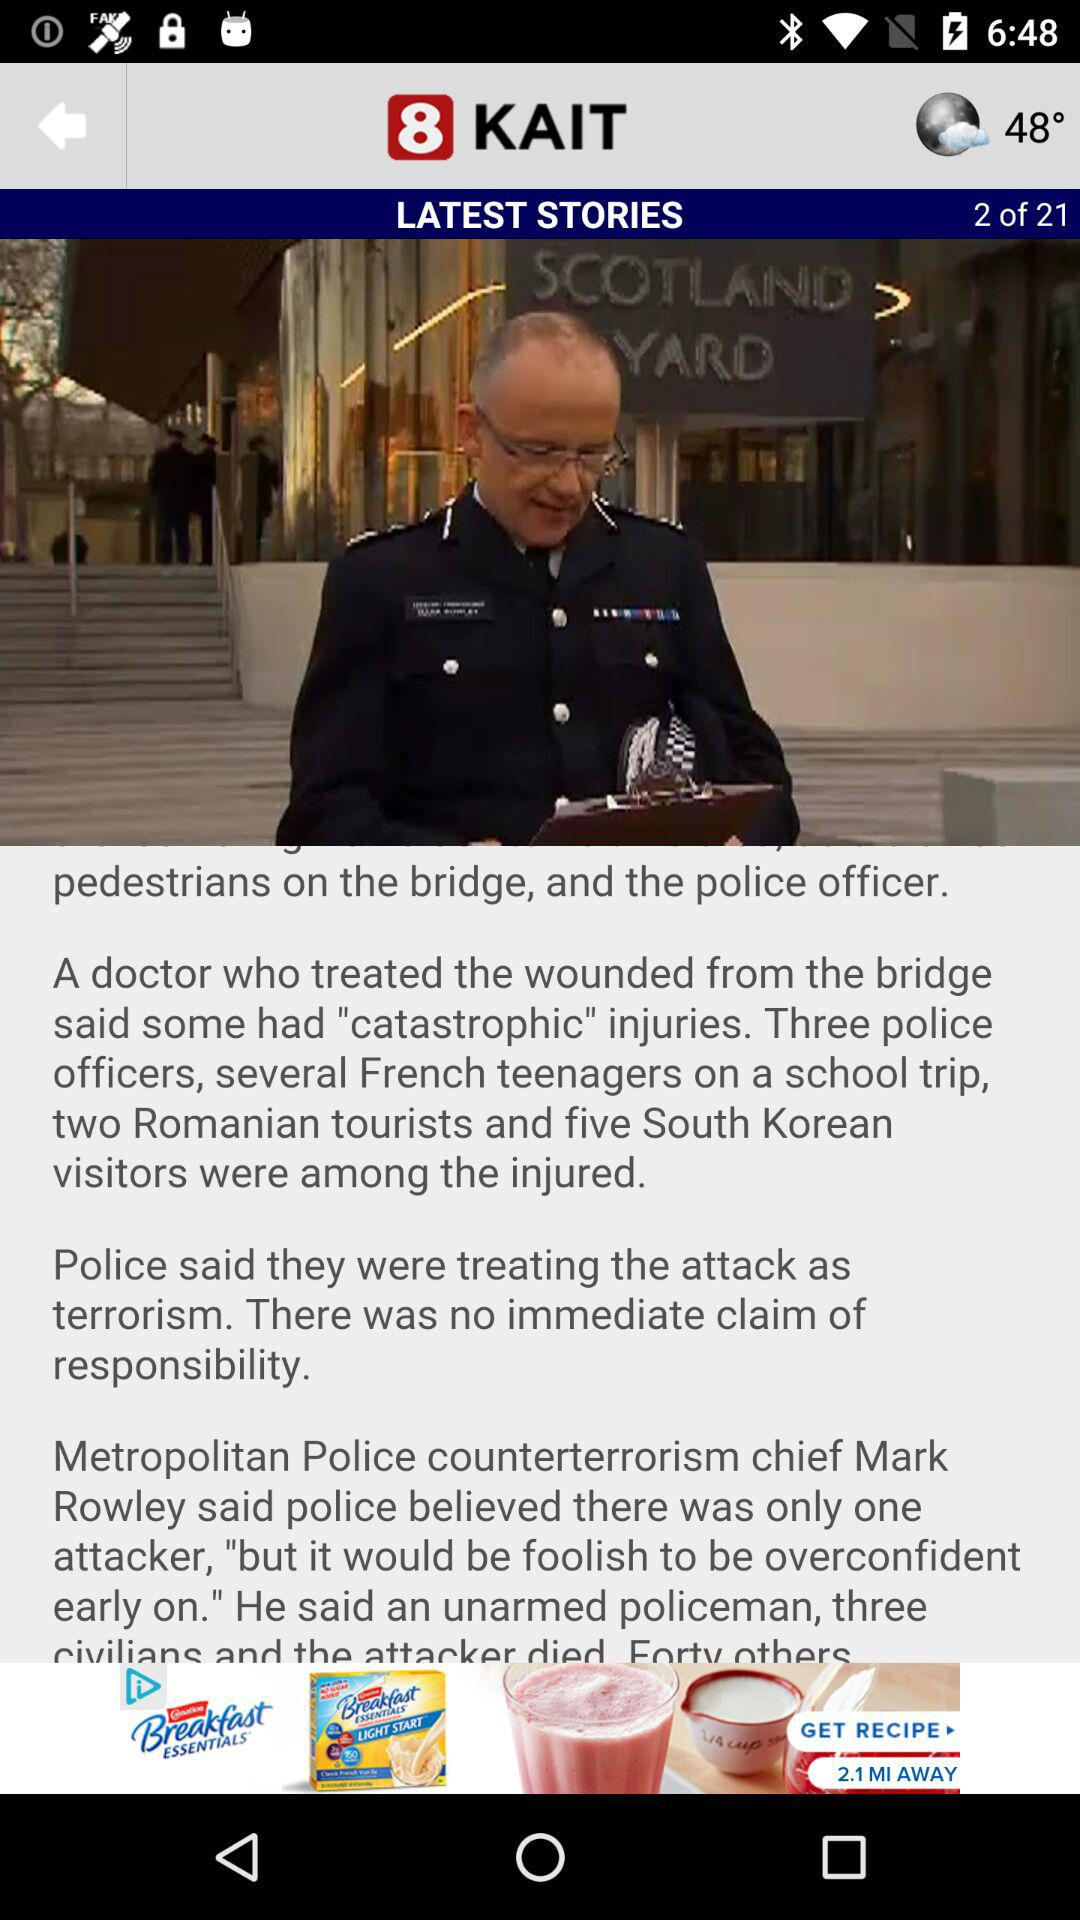What is the temperature? The temperature is 48°. 